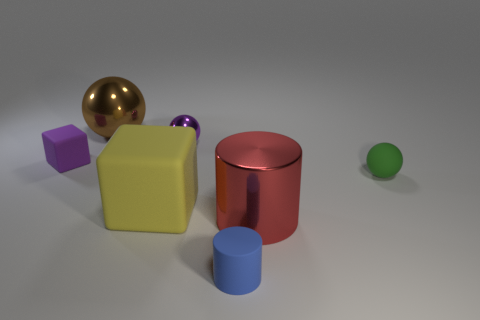Add 3 purple cylinders. How many objects exist? 10 Subtract all blocks. How many objects are left? 5 Subtract all blue rubber things. Subtract all purple matte cubes. How many objects are left? 5 Add 6 cubes. How many cubes are left? 8 Add 3 small blue things. How many small blue things exist? 4 Subtract 0 cyan blocks. How many objects are left? 7 